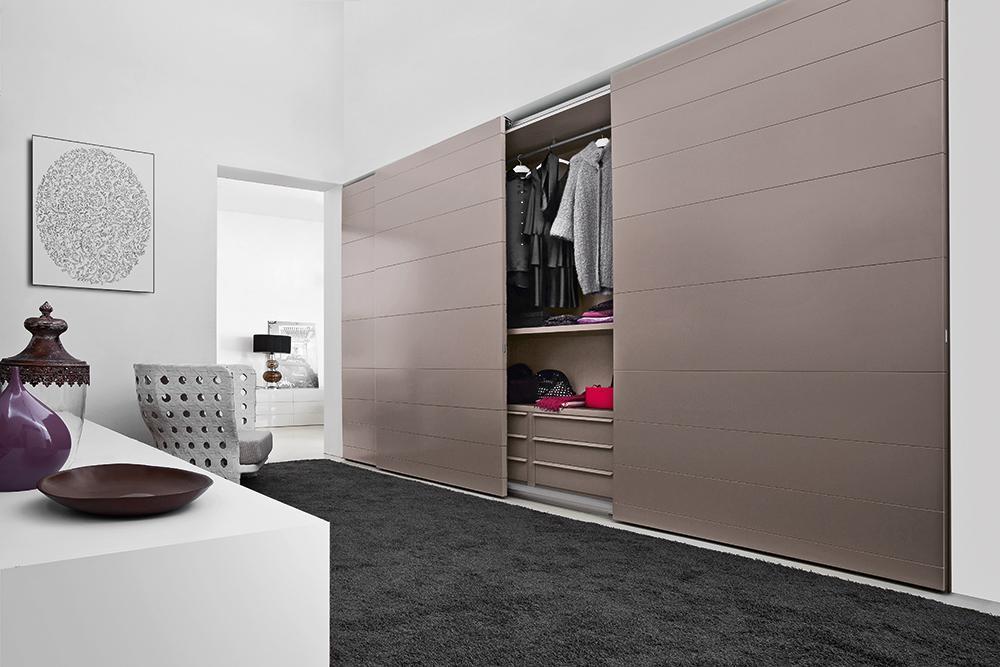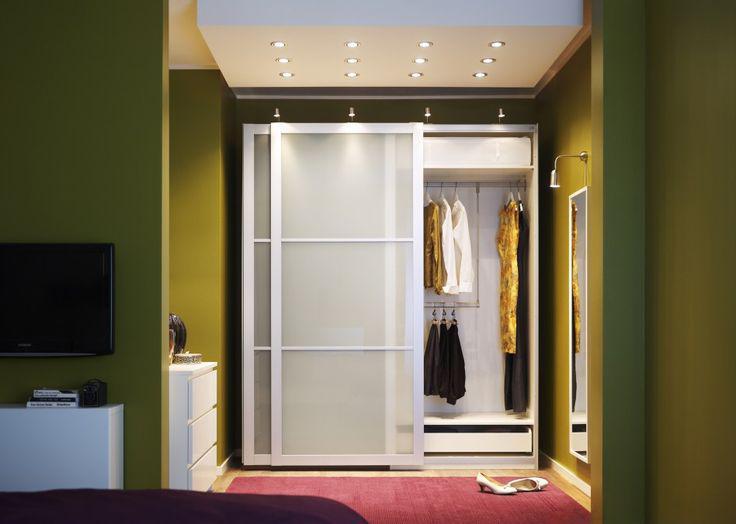The first image is the image on the left, the second image is the image on the right. Assess this claim about the two images: "The left image features a wide-open sliding 'barn style' wooden double door with a black bar at the top, and the right image shows a single barn-style wood plank door.". Correct or not? Answer yes or no. No. The first image is the image on the left, the second image is the image on the right. Analyze the images presented: Is the assertion "The left and right image contains a total of three brown wooden hanging doors." valid? Answer yes or no. No. The first image is the image on the left, the second image is the image on the right. Given the left and right images, does the statement "The left image features a 'barn style' wood-paneled double door with a black bar at the top, and the right image shows a single barn-style wood plank door." hold true? Answer yes or no. No. The first image is the image on the left, the second image is the image on the right. For the images displayed, is the sentence "The left and right image contains a total of three brown wooden hanging doors." factually correct? Answer yes or no. No. 